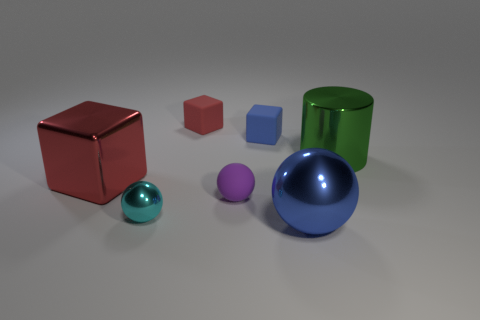Add 1 tiny brown things. How many objects exist? 8 Subtract all cylinders. How many objects are left? 6 Add 2 small blue rubber objects. How many small blue rubber objects are left? 3 Add 1 large metal cylinders. How many large metal cylinders exist? 2 Subtract 0 yellow blocks. How many objects are left? 7 Subtract all big blue metal balls. Subtract all large blocks. How many objects are left? 5 